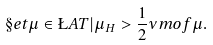Convert formula to latex. <formula><loc_0><loc_0><loc_500><loc_500>\S e t { \mu \in \L A T | \mu _ { H } > \frac { 1 } { 2 } \nu m o f { \mu } } .</formula> 